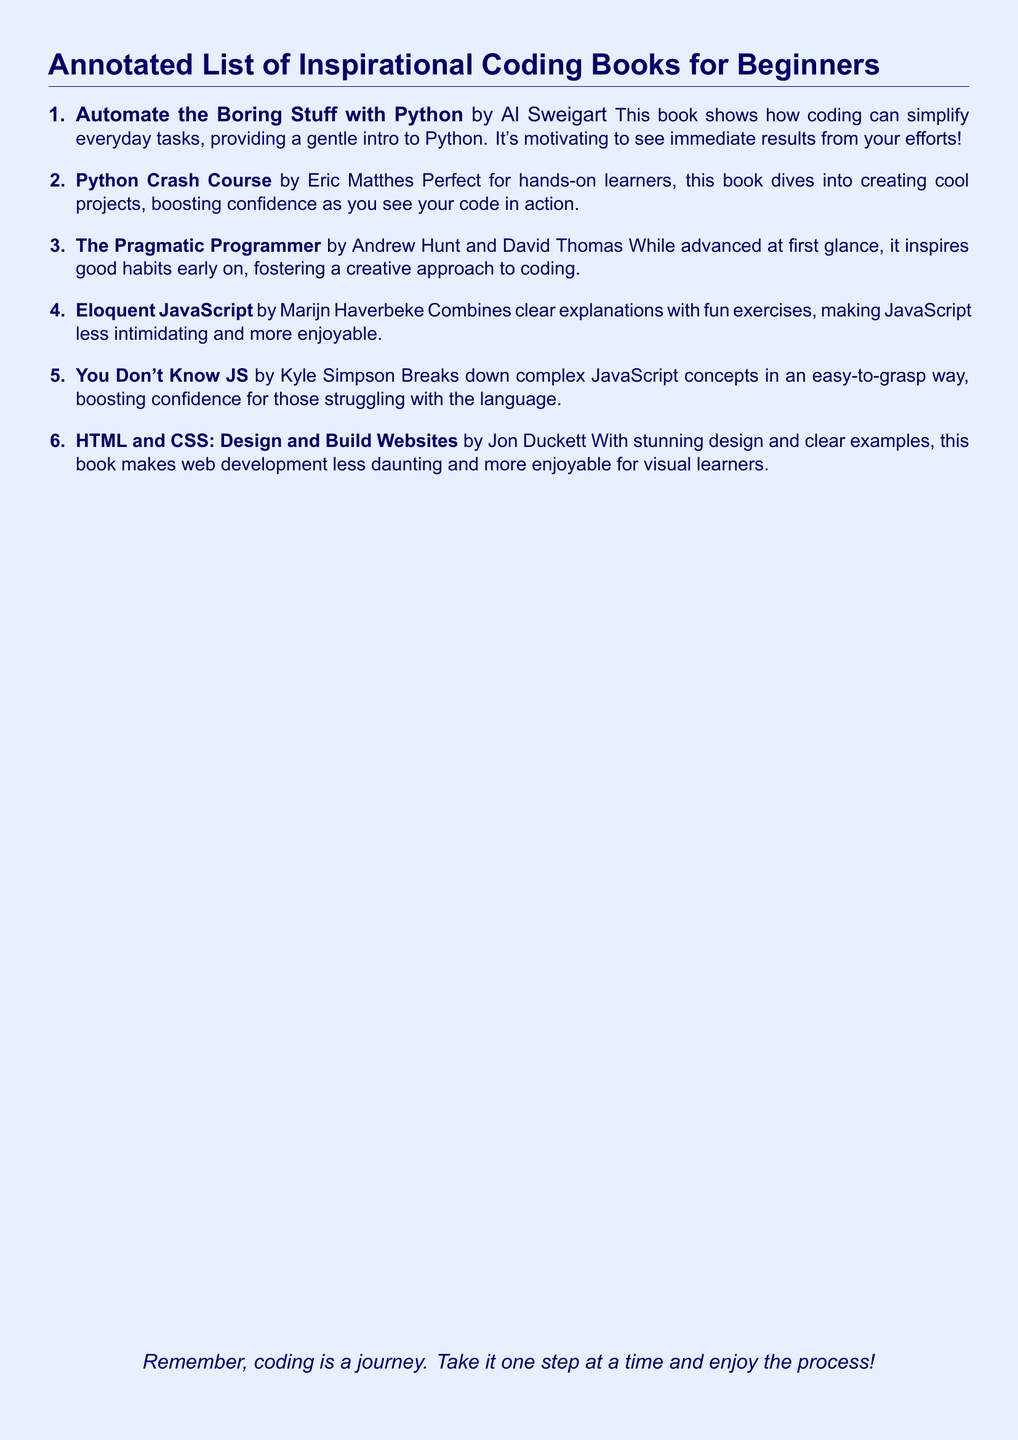What is the title of the first book? The title of the first book is listed in the document as it introduces the book by Al Sweigart.
Answer: Automate the Boring Stuff with Python Who is the author of "Eloquent JavaScript"? The author of "Eloquent JavaScript" is provided in the entry, which is part of the document's annotated list.
Answer: Marijn Haverbeke How many books are in the list? The document contains a total number of books, which is indicated in the enumeration format.
Answer: Six What is one of the main themes of "Python Crash Course"? The document summarizes this book, mentioning a key aspect that enhances the user's experience of coding through practical projects.
Answer: Hands-on learners Which book focuses on web development? This question requires identifying a specific title from the list that pertains to web development, as highlighted in the document.
Answer: HTML and CSS: Design and Build Websites What does the document encourage at the end? The final statement in the document provides a motivational message regarding the coding journey.
Answer: Remember, coding is a journey 